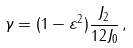<formula> <loc_0><loc_0><loc_500><loc_500>\gamma = ( 1 - \varepsilon ^ { 2 } ) \frac { J _ { 2 } } { 1 2 J _ { 0 } } \, ,</formula> 